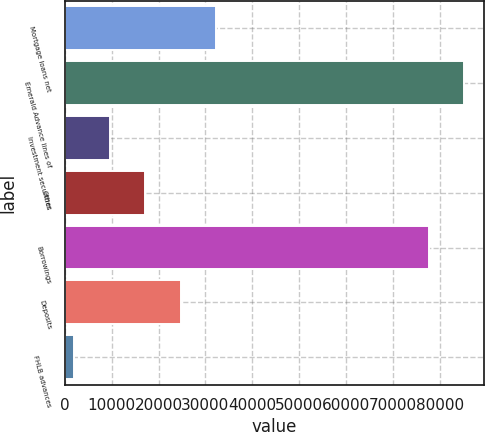Convert chart to OTSL. <chart><loc_0><loc_0><loc_500><loc_500><bar_chart><fcel>Mortgage loans net<fcel>Emerald Advance lines of<fcel>Investment securities<fcel>Other<fcel>Borrowings<fcel>Deposits<fcel>FHLB advances<nl><fcel>32354.6<fcel>85248.4<fcel>9586.4<fcel>17175.8<fcel>77659<fcel>24765.2<fcel>1997<nl></chart> 